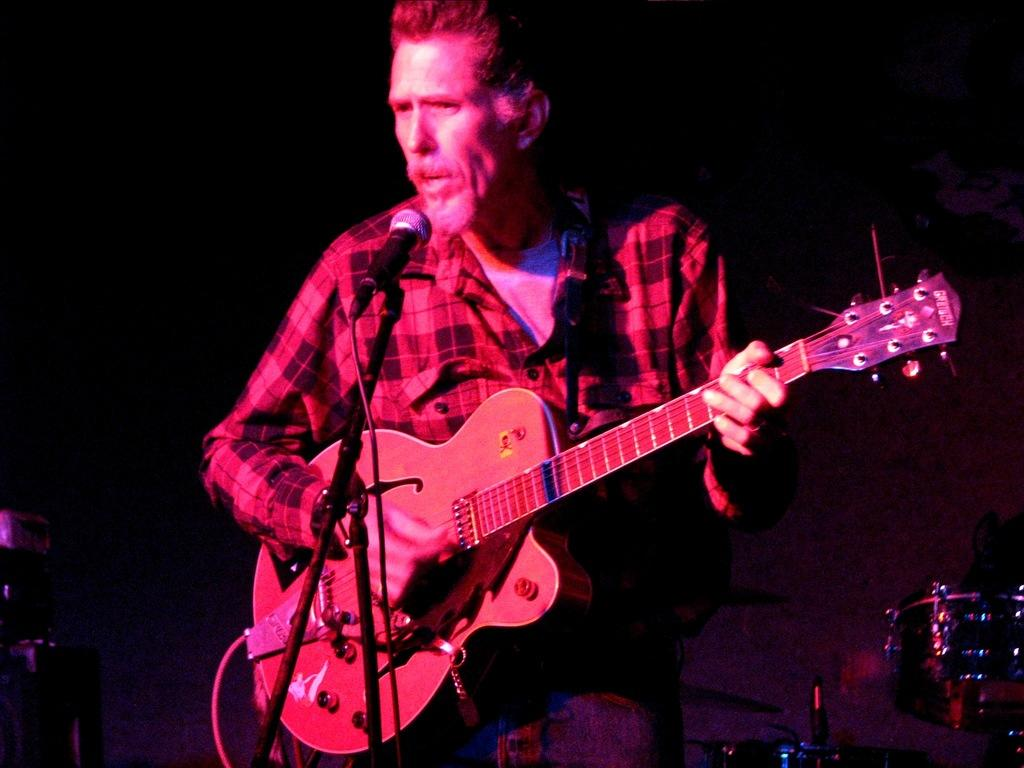Who is the main subject in the image? There is a man in the image. What is the man holding in the image? The man is holding a guitar. What is the guitar positioned in front of? The guitar is in front of a mic. What is the primary function of the guitar? The guitar is a musical instrument. Can you tell me how many kittens are playing with the guitar in the image? There are no kittens present in the image; it features a man holding a guitar in front of a mic. What method is used to measure the sound produced by the guitar in the image? The image does not show any method for measuring the sound produced by the guitar; it only shows the guitar in front of a mic. 